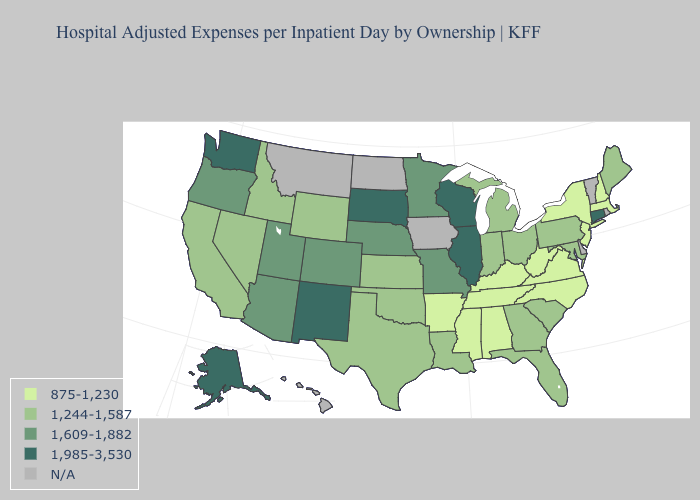What is the highest value in the MidWest ?
Be succinct. 1,985-3,530. Among the states that border South Dakota , which have the lowest value?
Be succinct. Wyoming. Name the states that have a value in the range 1,609-1,882?
Write a very short answer. Arizona, Colorado, Minnesota, Missouri, Nebraska, Oregon, Utah. Is the legend a continuous bar?
Write a very short answer. No. What is the highest value in states that border Wyoming?
Concise answer only. 1,985-3,530. What is the lowest value in the USA?
Write a very short answer. 875-1,230. What is the value of New Hampshire?
Give a very brief answer. 875-1,230. What is the value of Hawaii?
Concise answer only. N/A. Name the states that have a value in the range 1,609-1,882?
Give a very brief answer. Arizona, Colorado, Minnesota, Missouri, Nebraska, Oregon, Utah. How many symbols are there in the legend?
Short answer required. 5. What is the value of Missouri?
Be succinct. 1,609-1,882. What is the value of Michigan?
Write a very short answer. 1,244-1,587. Does Georgia have the highest value in the USA?
Write a very short answer. No. Does New Hampshire have the lowest value in the Northeast?
Answer briefly. Yes. What is the highest value in states that border Idaho?
Concise answer only. 1,985-3,530. 